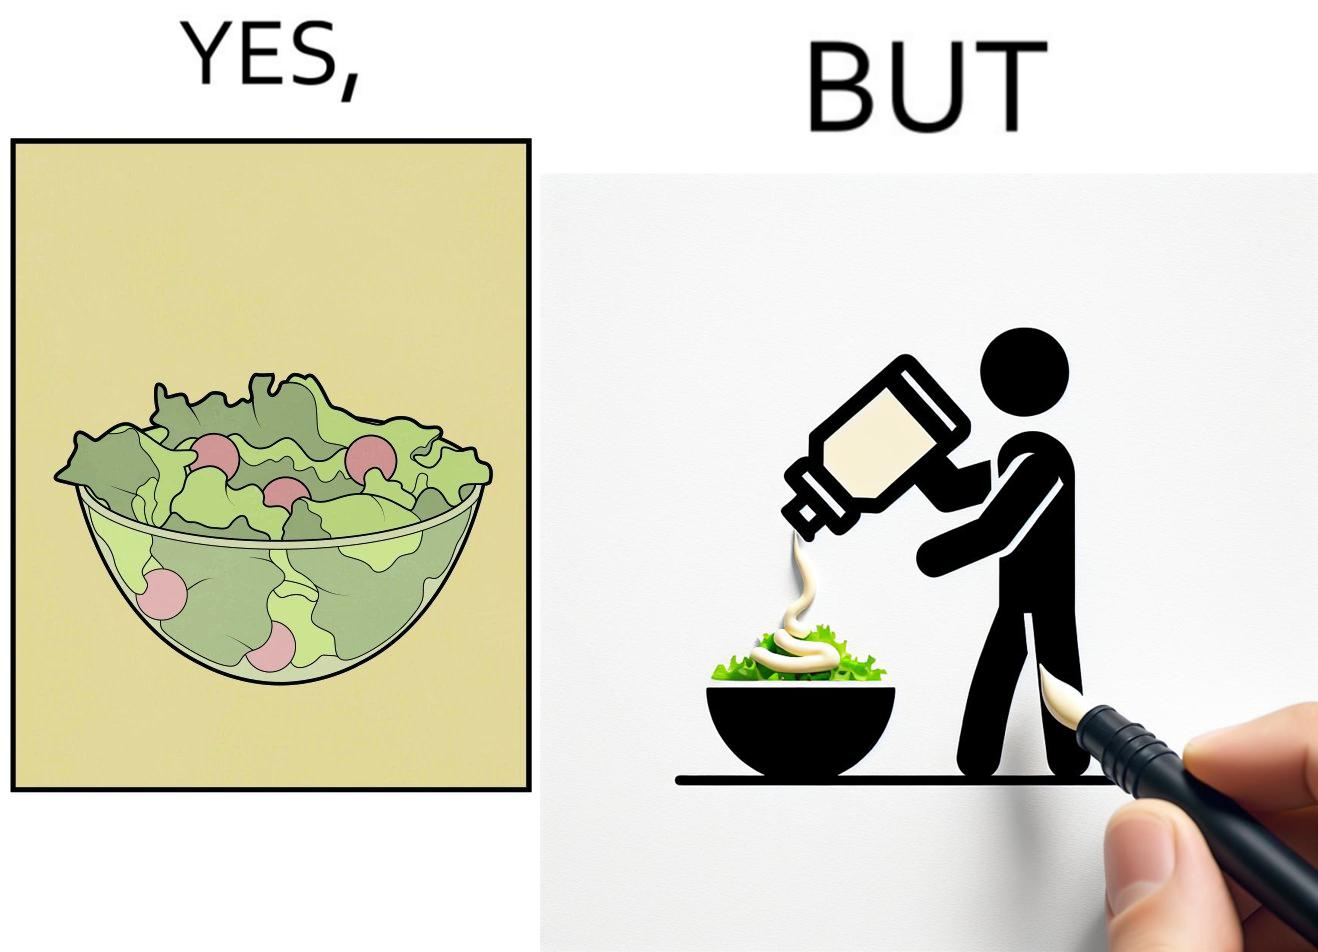Explain why this image is satirical. The image is ironical, as salad in a bowl by itself is very healthy. However, when people have it with Mayonnaise sauce to improve the taste, it is not healthy anymore, and defeats the point of having nutrient-rich salad altogether. 